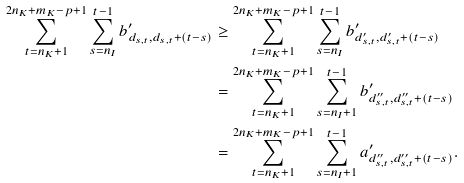Convert formula to latex. <formula><loc_0><loc_0><loc_500><loc_500>\sum _ { t = n _ { K } + 1 } ^ { 2 n _ { K } + m _ { K } - p + 1 } \sum _ { s = n _ { I } } ^ { t - 1 } b ^ { \prime } _ { d _ { s , t } , d _ { s , t } + ( t - s ) } & \geq \sum _ { t = n _ { K } + 1 } ^ { 2 n _ { K } + m _ { K } - p + 1 } \sum _ { s = n _ { I } } ^ { t - 1 } b ^ { \prime } _ { d ^ { \prime } _ { s , t } , d ^ { \prime } _ { s , t } + ( t - s ) } \\ & = \sum _ { t = n _ { K } + 1 } ^ { 2 n _ { K } + m _ { K } - p + 1 } \sum _ { s = n _ { I } + 1 } ^ { t - 1 } b ^ { \prime } _ { d ^ { \prime \prime } _ { s , t } , d ^ { \prime \prime } _ { s , t } + ( t - s ) } \\ & = \sum _ { t = n _ { K } + 1 } ^ { 2 n _ { K } + m _ { K } - p + 1 } \sum _ { s = n _ { I } + 1 } ^ { t - 1 } a ^ { \prime } _ { d ^ { \prime \prime } _ { s , t } , d ^ { \prime \prime } _ { s , t } + ( t - s ) } .</formula> 